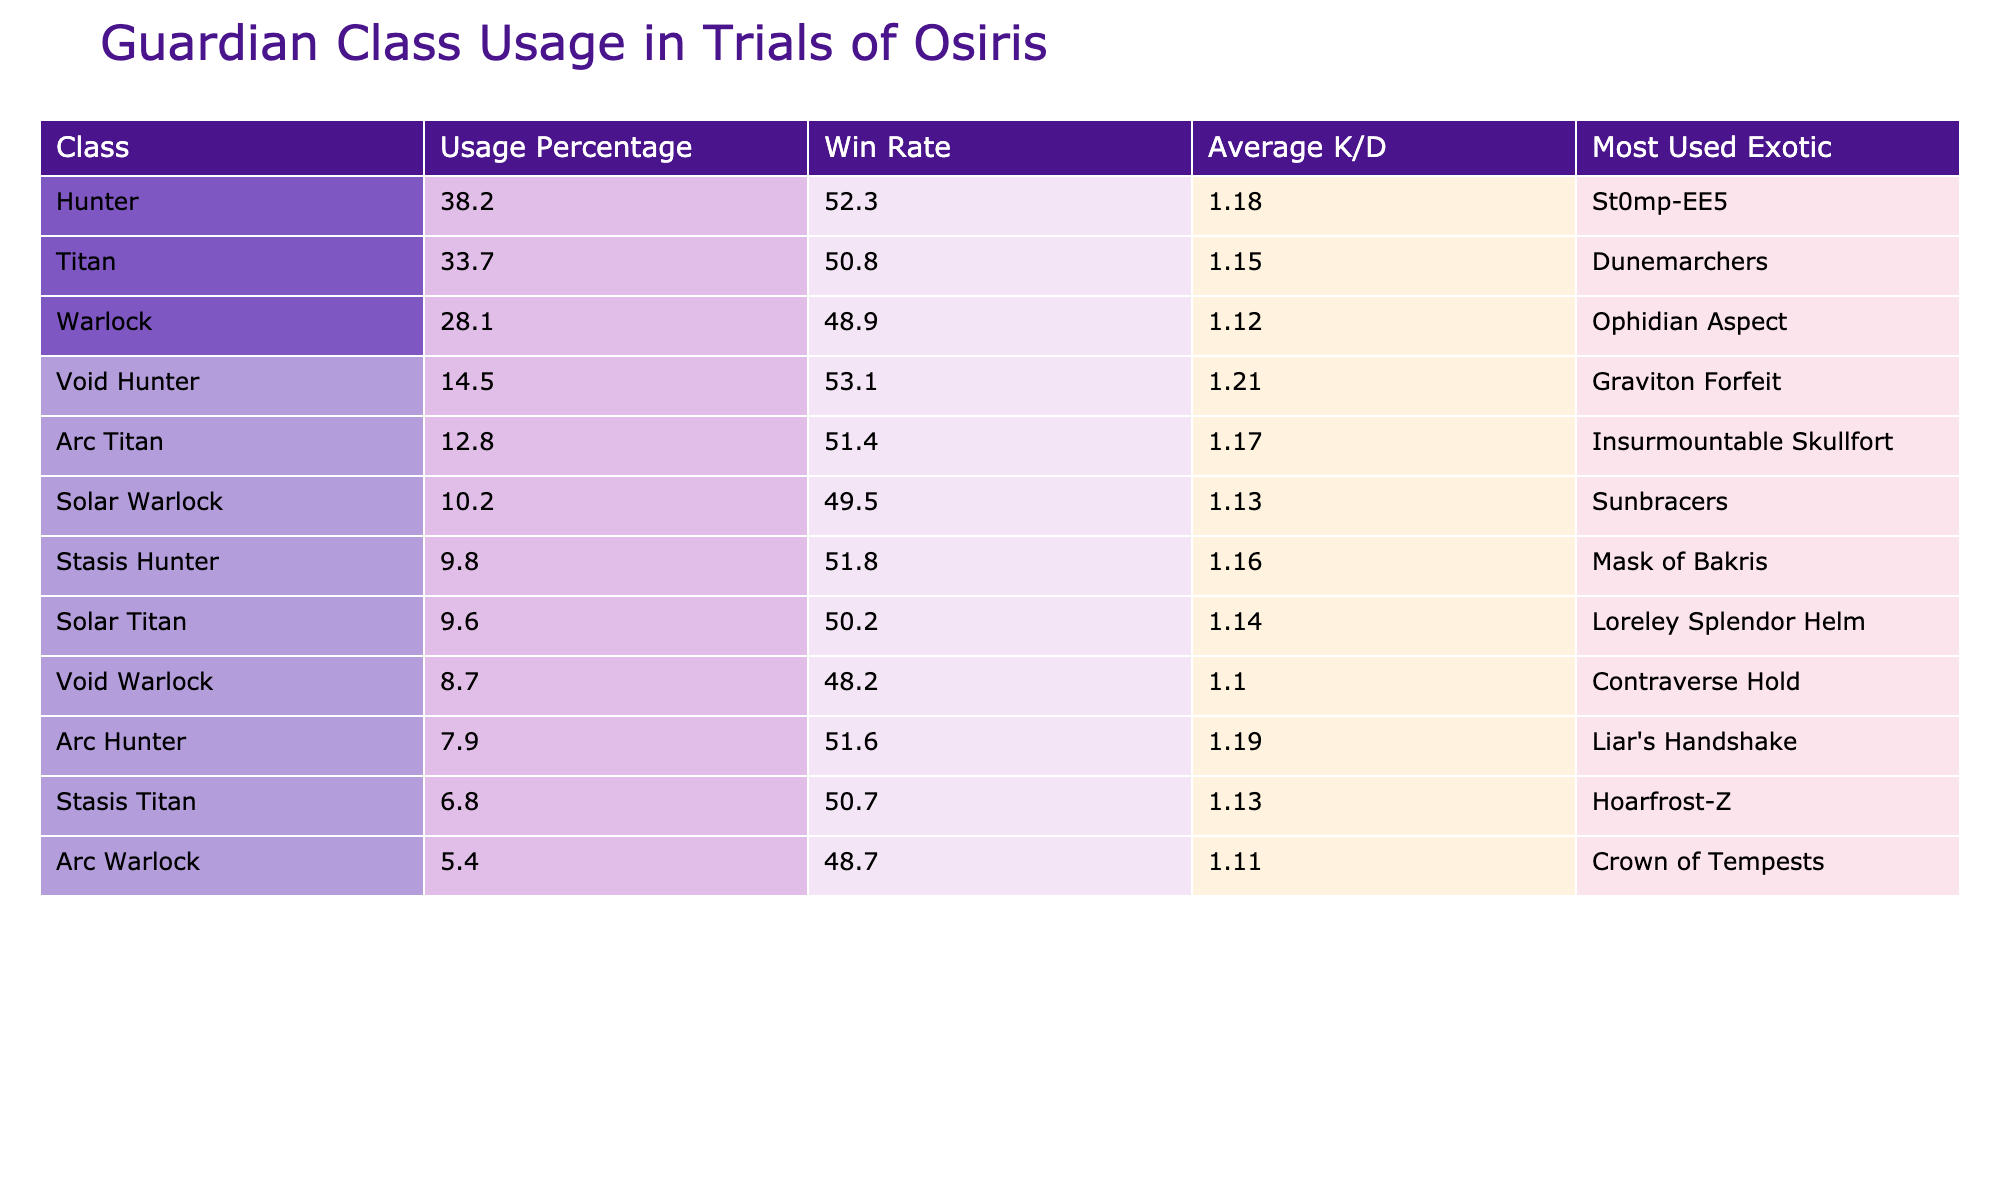What is the usage percentage of Hunters in Trials of Osiris? The table shows that the usage percentage for Hunters is specifically listed in the first row under the "Usage Percentage" column.
Answer: 38.2 What is the win rate for Warlocks in the Trials of Osiris? In the table, the win rate for Warlocks is provided in the row for "Warlock." Looking under the "Win Rate" column gives the value.
Answer: 48.9 Which class has the highest average K/D? To find the class with the highest average K/D, I compare the values under the "Average K/D" column for all classes to determine the maximum. The highest value in the column belongs to the "Void Hunter".
Answer: Void Hunter How does the win rate of Arc Titans compare to that of Solar Titans? First, I locate the win rates for both Arc Titans and Solar Titans in their respective rows. The Arc Titan has a win rate of 51.4%, while the Solar Titan has a win rate of 50.2%. Comparing these two values, Arc Titans have a higher win rate by 1.2%.
Answer: Arc Titans have a higher win rate What is the most used exotic for the Titan class? The most used exotic is listed in the "Most Used Exotic" column for the row corresponding to Titans. It indicates the specific exotic gear that is most commonly equipped by Titans.
Answer: Dunemarchers If you combine the usage percentages of all Hunter subclasses, what would it be? First, identify the usage percentages for all the Hunter subclasses: Hunter (38.2%), Void Hunter (14.5%), Arc Hunter (7.9%), and Stasis Hunter (9.8%). Next, add them: 38.2 + 14.5 + 7.9 + 9.8 = 70.4%.
Answer: 70.4 Is the average K/D of Warlocks greater than that of Titans? By examining the average K/D values for Warlocks (1.12) and Titans (1.15), it is evident that Warlocks have a lower average K/D compared to Titans. Thus, the statement is false.
Answer: No What was the total usage percentage for both Titan and Warlock classes combined? I find the usage percentages for Titans (33.7%) and Warlocks (28.1%). Adding these gives: 33.7 + 28.1 = 61.8%.
Answer: 61.8 Which class has the lowest win rate, and what is that win rate? The win rates for all classes are compared, and it is observed that the lowest win rate is for Warlocks at 48.9%. This pair identifies both the class and its corresponding win rate.
Answer: Warlock, 48.9 What percentage difference in usage is there between the Hunter and Titan classes? To find the percentage difference, subtract the Titan usage (33.7%) from Hunter usage (38.2%) to get 38.2 - 33.7 = 4.5%. Then, divide by the Titan usage and multiply by 100 to express it as a percentage: (4.5 / 33.7) * 100 ≈ 13.35%.
Answer: Approximately 13.35% 